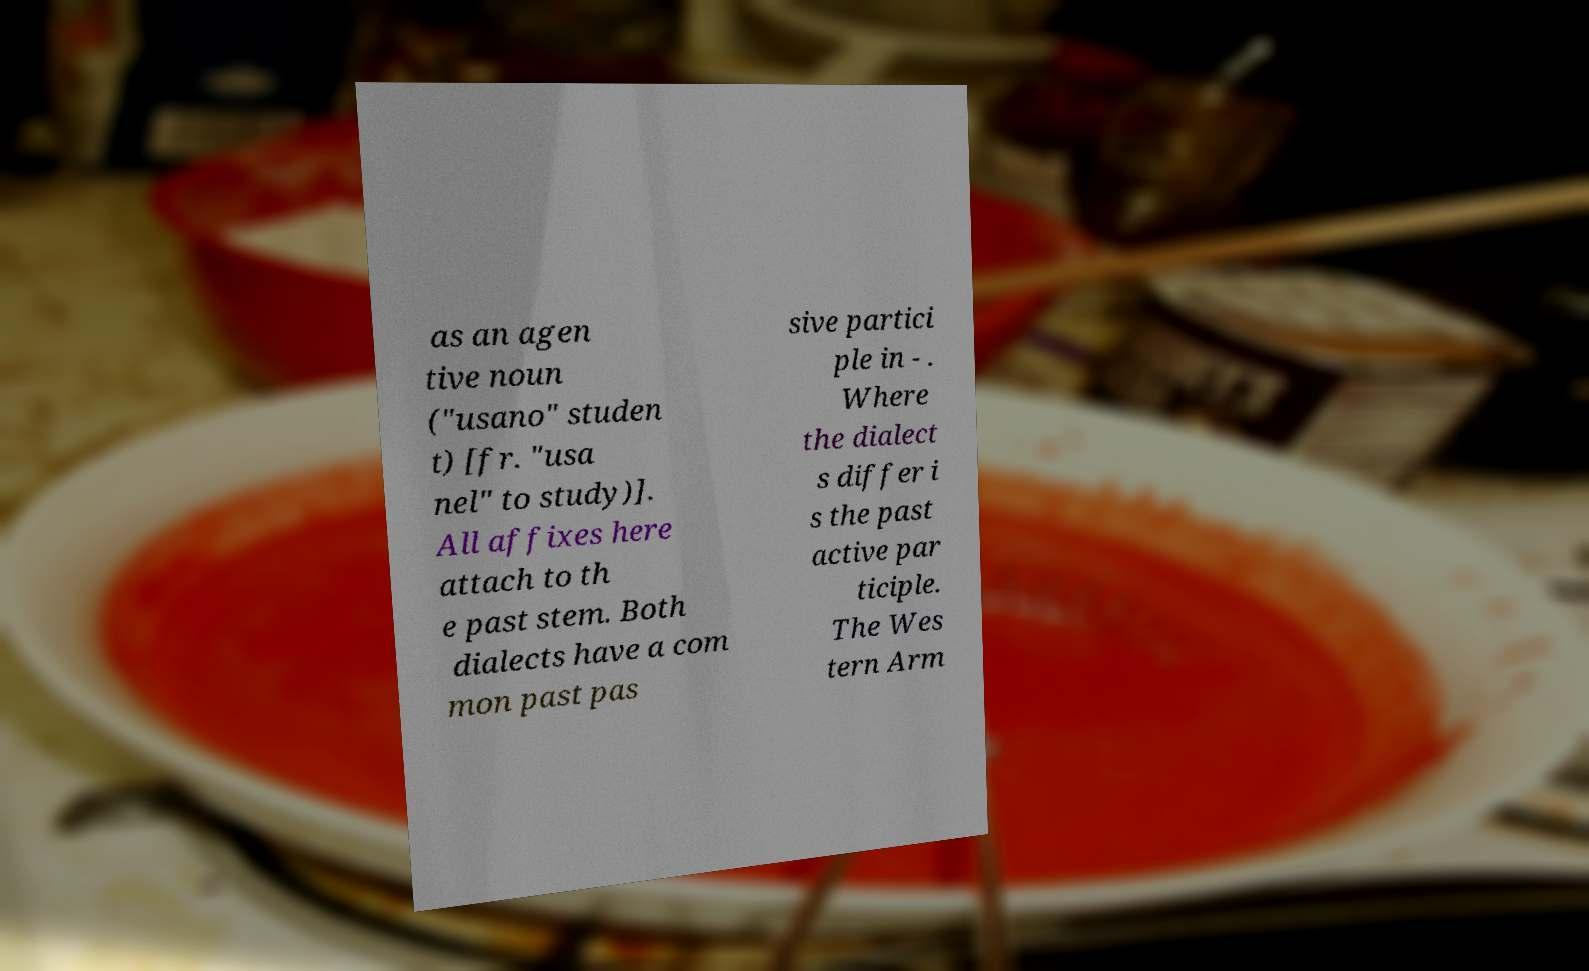There's text embedded in this image that I need extracted. Can you transcribe it verbatim? as an agen tive noun ("usano" studen t) [fr. "usa nel" to study)]. All affixes here attach to th e past stem. Both dialects have a com mon past pas sive partici ple in - . Where the dialect s differ i s the past active par ticiple. The Wes tern Arm 